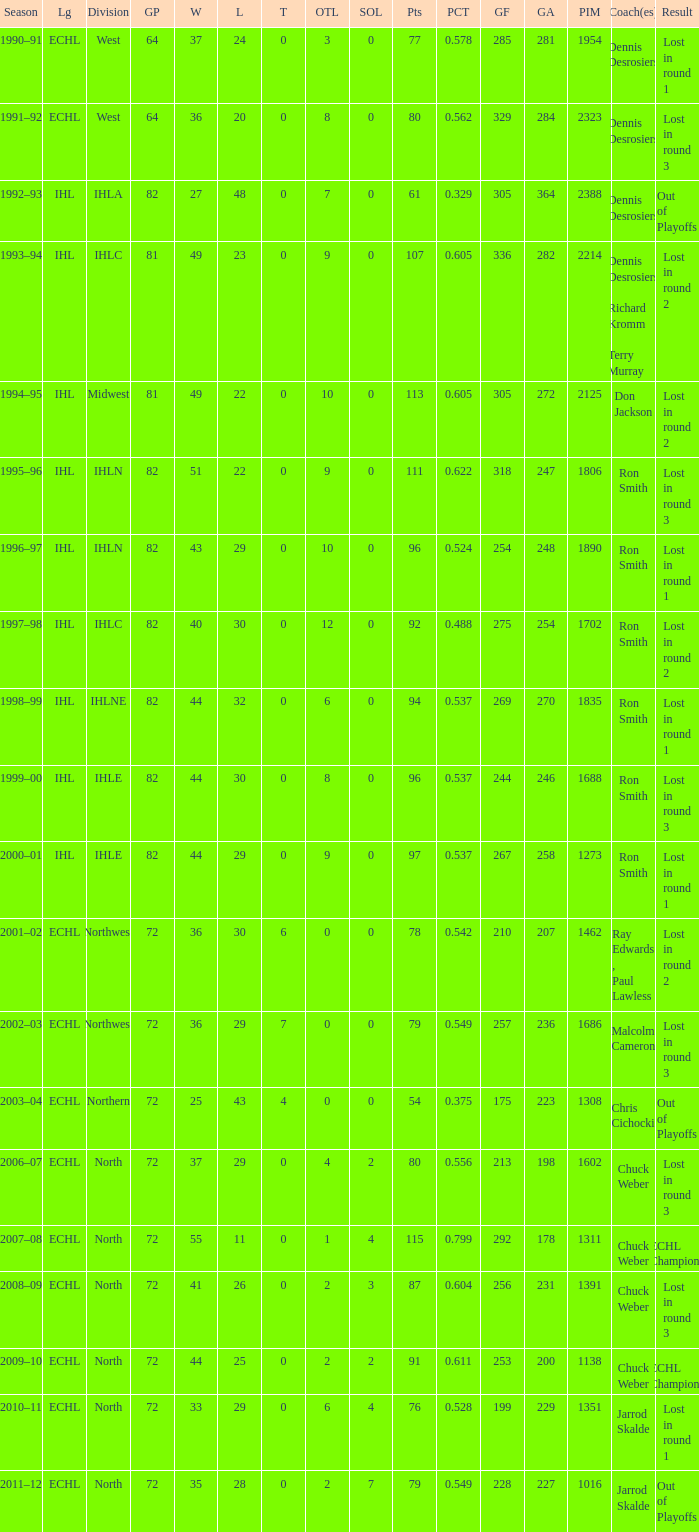How many season did the team lost in round 1 with a GP of 64? 1.0. 